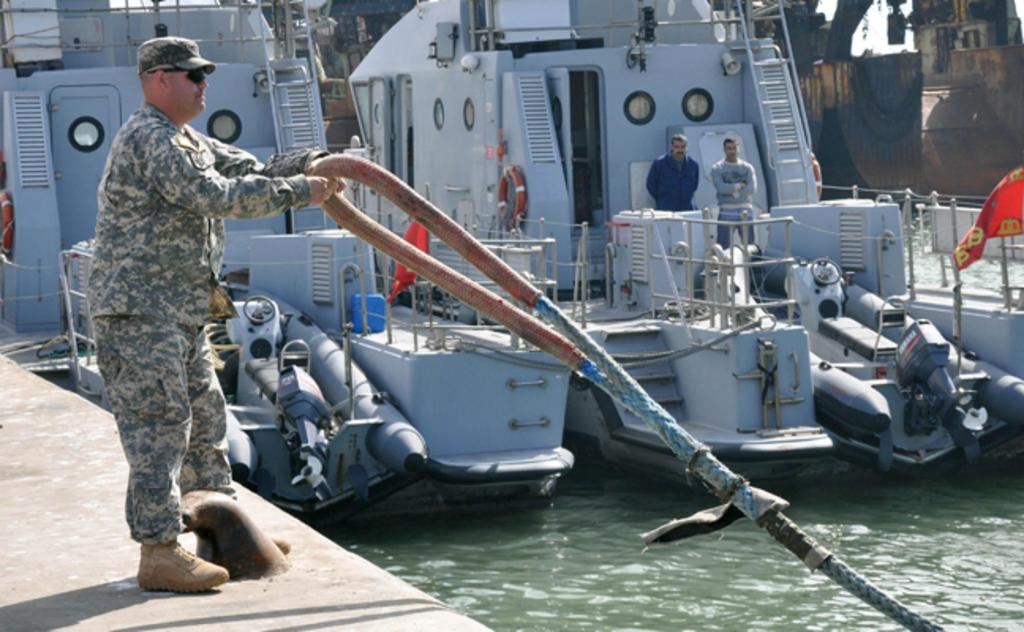Who is present in the image? There is a man in the image. What is the man wearing? The man is wearing a camouflage dress. What is the man holding in the image? The man is holding a rope. What can be seen in the water in the image? There are boats in the canal, and two persons are standing on the boats. What type of argument is taking place between the horses in the image? There are no horses present in the image, so no argument can be observed. 